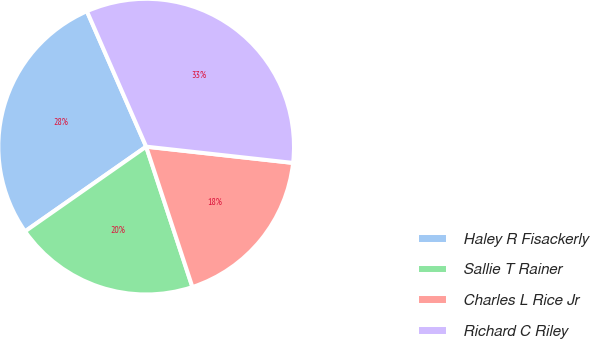<chart> <loc_0><loc_0><loc_500><loc_500><pie_chart><fcel>Haley R Fisackerly<fcel>Sallie T Rainer<fcel>Charles L Rice Jr<fcel>Richard C Riley<nl><fcel>28.15%<fcel>20.35%<fcel>18.18%<fcel>33.32%<nl></chart> 